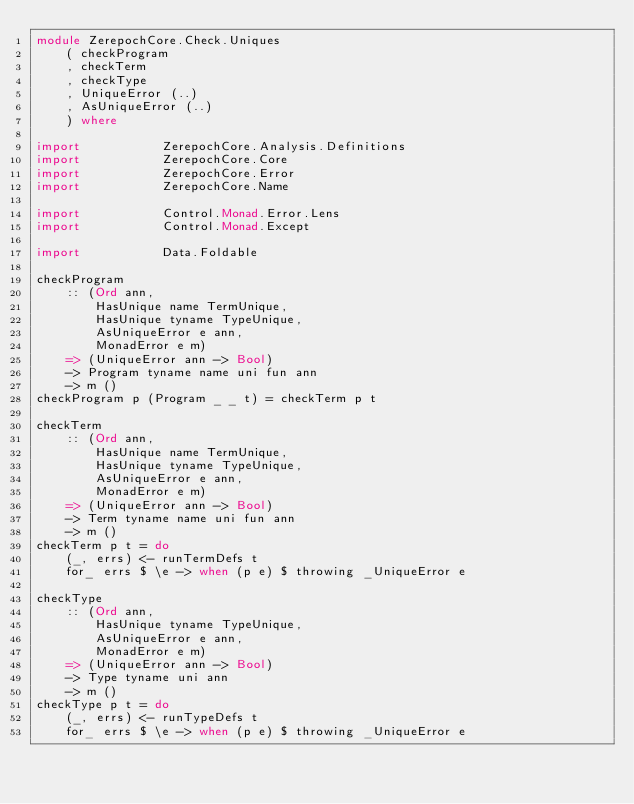<code> <loc_0><loc_0><loc_500><loc_500><_Haskell_>module ZerepochCore.Check.Uniques
    ( checkProgram
    , checkTerm
    , checkType
    , UniqueError (..)
    , AsUniqueError (..)
    ) where

import           ZerepochCore.Analysis.Definitions
import           ZerepochCore.Core
import           ZerepochCore.Error
import           ZerepochCore.Name

import           Control.Monad.Error.Lens
import           Control.Monad.Except

import           Data.Foldable

checkProgram
    :: (Ord ann,
        HasUnique name TermUnique,
        HasUnique tyname TypeUnique,
        AsUniqueError e ann,
        MonadError e m)
    => (UniqueError ann -> Bool)
    -> Program tyname name uni fun ann
    -> m ()
checkProgram p (Program _ _ t) = checkTerm p t

checkTerm
    :: (Ord ann,
        HasUnique name TermUnique,
        HasUnique tyname TypeUnique,
        AsUniqueError e ann,
        MonadError e m)
    => (UniqueError ann -> Bool)
    -> Term tyname name uni fun ann
    -> m ()
checkTerm p t = do
    (_, errs) <- runTermDefs t
    for_ errs $ \e -> when (p e) $ throwing _UniqueError e

checkType
    :: (Ord ann,
        HasUnique tyname TypeUnique,
        AsUniqueError e ann,
        MonadError e m)
    => (UniqueError ann -> Bool)
    -> Type tyname uni ann
    -> m ()
checkType p t = do
    (_, errs) <- runTypeDefs t
    for_ errs $ \e -> when (p e) $ throwing _UniqueError e
</code> 